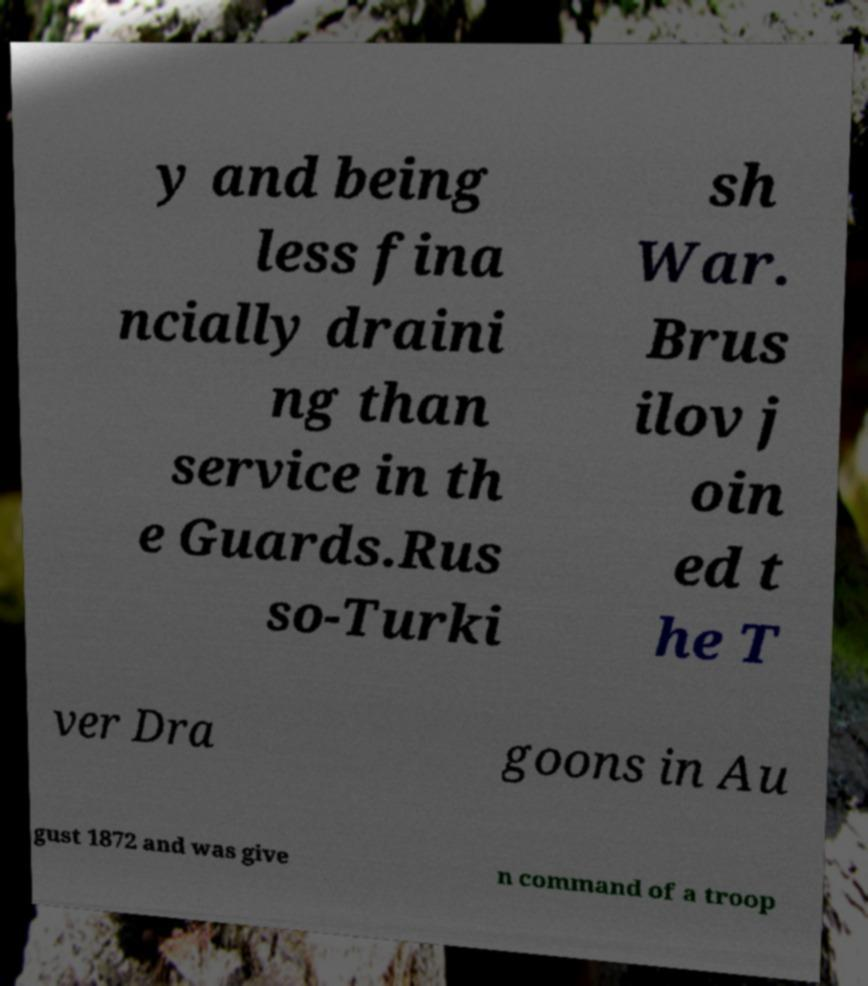Could you extract and type out the text from this image? y and being less fina ncially draini ng than service in th e Guards.Rus so-Turki sh War. Brus ilov j oin ed t he T ver Dra goons in Au gust 1872 and was give n command of a troop 